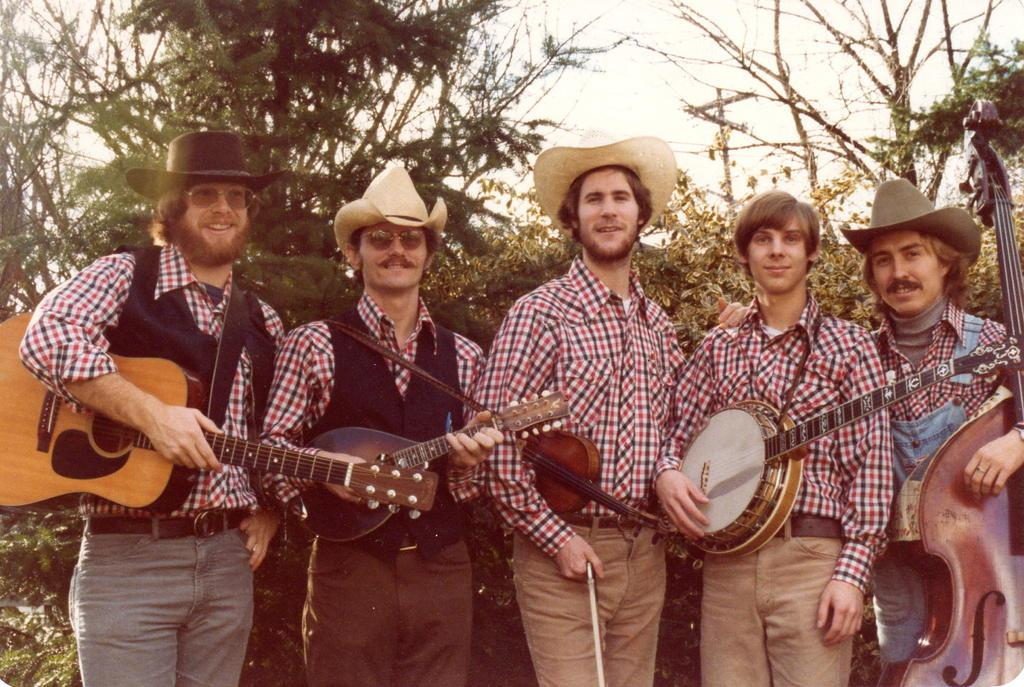How many people are in the image? There are people in the image, but the exact number is not specified. What are the people holding in their hands? The people are holding guitars in their hands. What type of seed can be seen growing in the image? There is no seed present in the image; it features people holding guitars. Can you hear the animals' voices in the image? There is no mention of animals or voices in the image; it only shows people holding guitars. 